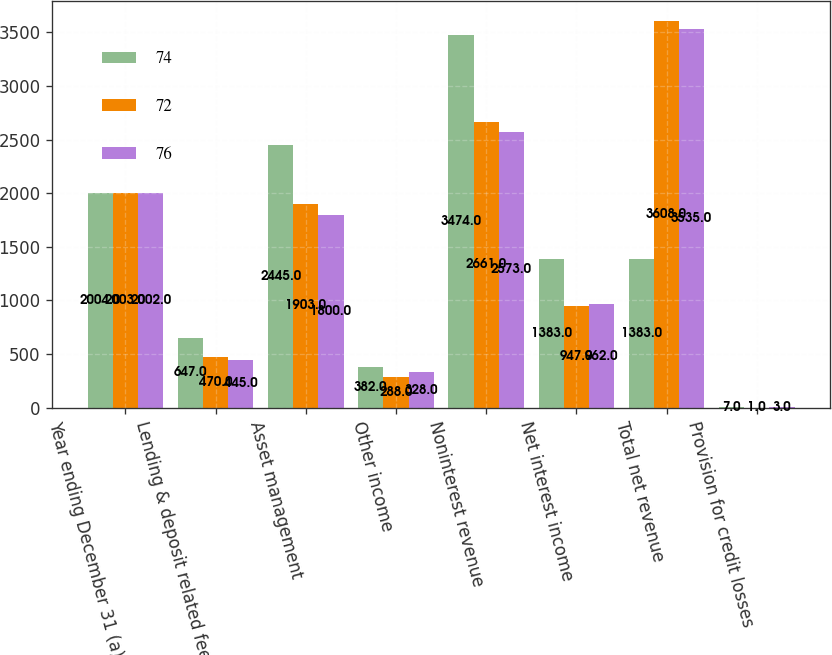<chart> <loc_0><loc_0><loc_500><loc_500><stacked_bar_chart><ecel><fcel>Year ending December 31 (a)<fcel>Lending & deposit related fees<fcel>Asset management<fcel>Other income<fcel>Noninterest revenue<fcel>Net interest income<fcel>Total net revenue<fcel>Provision for credit losses<nl><fcel>74<fcel>2004<fcel>647<fcel>2445<fcel>382<fcel>3474<fcel>1383<fcel>1383<fcel>7<nl><fcel>72<fcel>2003<fcel>470<fcel>1903<fcel>288<fcel>2661<fcel>947<fcel>3608<fcel>1<nl><fcel>76<fcel>2002<fcel>445<fcel>1800<fcel>328<fcel>2573<fcel>962<fcel>3535<fcel>3<nl></chart> 